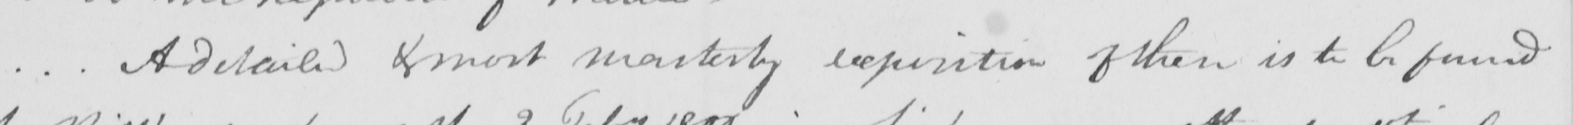What does this handwritten line say? .  .  . A detailed & most masterly exposition of these is to be found 